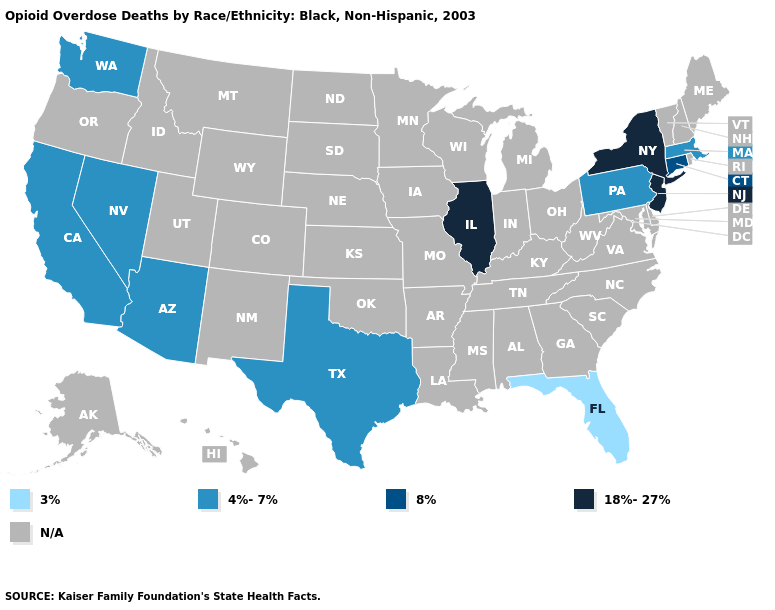Name the states that have a value in the range 4%-7%?
Quick response, please. Arizona, California, Massachusetts, Nevada, Pennsylvania, Texas, Washington. What is the value of Illinois?
Concise answer only. 18%-27%. Does Florida have the lowest value in the USA?
Short answer required. Yes. Name the states that have a value in the range 18%-27%?
Short answer required. Illinois, New Jersey, New York. What is the lowest value in the MidWest?
Be succinct. 18%-27%. Which states have the lowest value in the USA?
Keep it brief. Florida. Does the map have missing data?
Be succinct. Yes. Name the states that have a value in the range N/A?
Concise answer only. Alabama, Alaska, Arkansas, Colorado, Delaware, Georgia, Hawaii, Idaho, Indiana, Iowa, Kansas, Kentucky, Louisiana, Maine, Maryland, Michigan, Minnesota, Mississippi, Missouri, Montana, Nebraska, New Hampshire, New Mexico, North Carolina, North Dakota, Ohio, Oklahoma, Oregon, Rhode Island, South Carolina, South Dakota, Tennessee, Utah, Vermont, Virginia, West Virginia, Wisconsin, Wyoming. What is the value of Pennsylvania?
Keep it brief. 4%-7%. Among the states that border Nevada , which have the lowest value?
Concise answer only. Arizona, California. Which states have the lowest value in the South?
Short answer required. Florida. What is the lowest value in the MidWest?
Give a very brief answer. 18%-27%. 